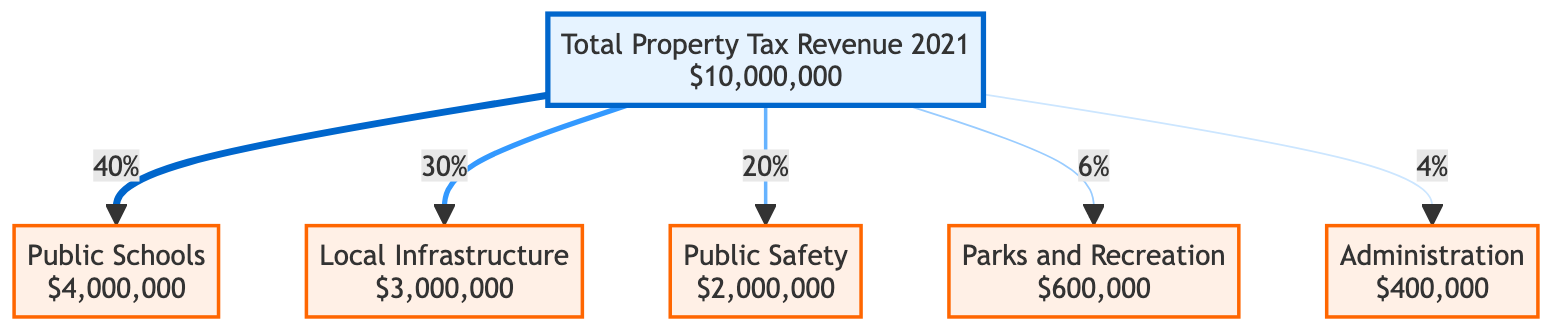What is the total property tax revenue for 2021? The diagram specifies that the total property tax revenue for the year 2021 is listed directly as "$10,000,000" at the top of the diagram.
Answer: $10,000,000 How much funding is allocated to public schools? The diagram shows that the allocation for public schools is "$4,000,000", which is detailed in the node that represents public schools.
Answer: $4,000,000 What percentage of the total revenue is allocated to parks and recreation? The diagram indicates that parks and recreation receive a funding allocation of "6%", represented in the link coming from the total revenue node.
Answer: 6% Which sector receives the least amount of funding? Looking at the allocation amounts in the diagram, the node for administration shows "$400,000", which is the smallest allocation compared to the other sectors.
Answer: Administration What is the combined percentage allocation for local infrastructure and public safety? From the diagram, local infrastructure is allocated "30%" and public safety "20%". Adding these percentages together gives 30% + 20% = 50%.
Answer: 50% What is the amount allocated to public safety? The allocation for public safety is listed as "$2,000,000" in the appropriate node connected to the total revenue.
Answer: $2,000,000 If the total property tax revenue were to increase by 10%, what would be the new allocation for parks and recreation? A 10% increase on $10,000,000 leads to an updated revenue of $11,000,000. Parks and recreation get 6% of that, calculated as $11,000,000 * 0.06 = $660,000.
Answer: $660,000 What two sectors together account for more than half of the total property tax revenue? Calculating the allocations, public schools ($4,000,000) and local infrastructure ($3,000,000) sum to $7,000,000 which is more than half of $10,000,000, representing 70% of the total revenue.
Answer: Public Schools and Local Infrastructure What is the total amount allocated to administration and parks and recreation combined? The diagram indicates that administration is "$400,000" and parks and recreation is "$600,000". Adding these amounts together gives $400,000 + $600,000 = $1,000,000.
Answer: $1,000,000 